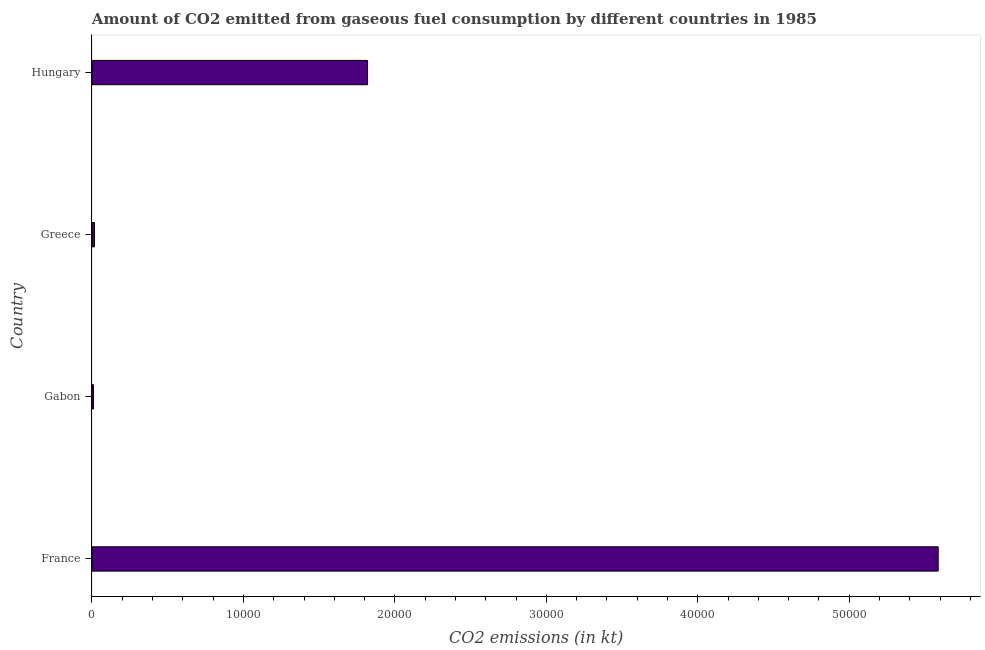Does the graph contain any zero values?
Your answer should be very brief. No. What is the title of the graph?
Your answer should be compact. Amount of CO2 emitted from gaseous fuel consumption by different countries in 1985. What is the label or title of the X-axis?
Your answer should be very brief. CO2 emissions (in kt). What is the co2 emissions from gaseous fuel consumption in Greece?
Your response must be concise. 165.01. Across all countries, what is the maximum co2 emissions from gaseous fuel consumption?
Provide a succinct answer. 5.59e+04. Across all countries, what is the minimum co2 emissions from gaseous fuel consumption?
Your answer should be very brief. 95.34. In which country was the co2 emissions from gaseous fuel consumption minimum?
Your answer should be compact. Gabon. What is the sum of the co2 emissions from gaseous fuel consumption?
Provide a succinct answer. 7.43e+04. What is the difference between the co2 emissions from gaseous fuel consumption in France and Hungary?
Provide a short and direct response. 3.77e+04. What is the average co2 emissions from gaseous fuel consumption per country?
Your response must be concise. 1.86e+04. What is the median co2 emissions from gaseous fuel consumption?
Your response must be concise. 9180.33. What is the ratio of the co2 emissions from gaseous fuel consumption in Gabon to that in Hungary?
Ensure brevity in your answer.  0.01. Is the difference between the co2 emissions from gaseous fuel consumption in France and Greece greater than the difference between any two countries?
Offer a terse response. No. What is the difference between the highest and the second highest co2 emissions from gaseous fuel consumption?
Provide a succinct answer. 3.77e+04. What is the difference between the highest and the lowest co2 emissions from gaseous fuel consumption?
Make the answer very short. 5.58e+04. In how many countries, is the co2 emissions from gaseous fuel consumption greater than the average co2 emissions from gaseous fuel consumption taken over all countries?
Your answer should be very brief. 1. How many countries are there in the graph?
Offer a very short reply. 4. What is the difference between two consecutive major ticks on the X-axis?
Offer a very short reply. 10000. Are the values on the major ticks of X-axis written in scientific E-notation?
Your answer should be compact. No. What is the CO2 emissions (in kt) in France?
Keep it short and to the point. 5.59e+04. What is the CO2 emissions (in kt) in Gabon?
Offer a terse response. 95.34. What is the CO2 emissions (in kt) of Greece?
Offer a very short reply. 165.01. What is the CO2 emissions (in kt) of Hungary?
Your response must be concise. 1.82e+04. What is the difference between the CO2 emissions (in kt) in France and Gabon?
Your answer should be very brief. 5.58e+04. What is the difference between the CO2 emissions (in kt) in France and Greece?
Give a very brief answer. 5.57e+04. What is the difference between the CO2 emissions (in kt) in France and Hungary?
Your response must be concise. 3.77e+04. What is the difference between the CO2 emissions (in kt) in Gabon and Greece?
Ensure brevity in your answer.  -69.67. What is the difference between the CO2 emissions (in kt) in Gabon and Hungary?
Keep it short and to the point. -1.81e+04. What is the difference between the CO2 emissions (in kt) in Greece and Hungary?
Your answer should be very brief. -1.80e+04. What is the ratio of the CO2 emissions (in kt) in France to that in Gabon?
Give a very brief answer. 586. What is the ratio of the CO2 emissions (in kt) in France to that in Greece?
Your answer should be compact. 338.58. What is the ratio of the CO2 emissions (in kt) in France to that in Hungary?
Your answer should be compact. 3.07. What is the ratio of the CO2 emissions (in kt) in Gabon to that in Greece?
Your answer should be very brief. 0.58. What is the ratio of the CO2 emissions (in kt) in Gabon to that in Hungary?
Provide a short and direct response. 0.01. What is the ratio of the CO2 emissions (in kt) in Greece to that in Hungary?
Your answer should be compact. 0.01. 